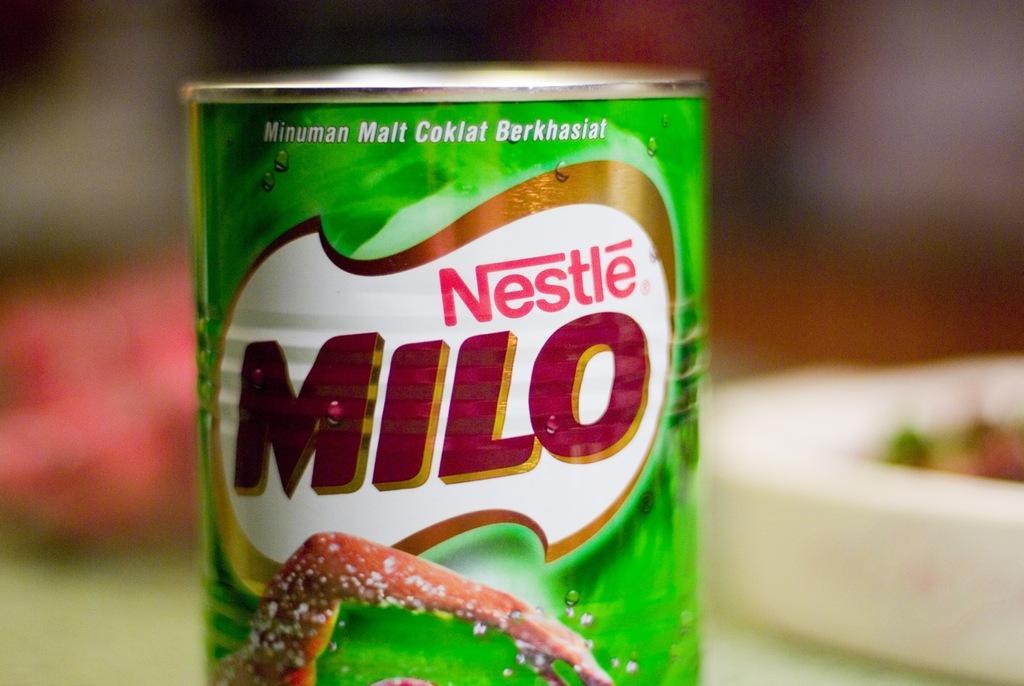Describe this image in one or two sentences. In the center of the image, we can see a milo drink jar. 